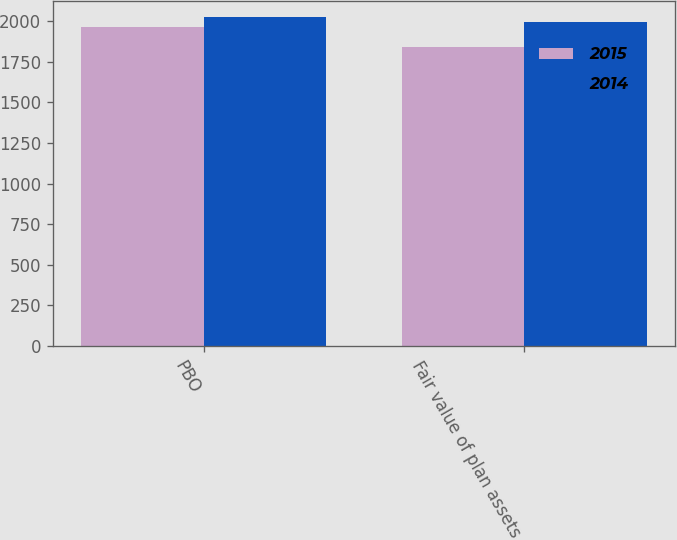<chart> <loc_0><loc_0><loc_500><loc_500><stacked_bar_chart><ecel><fcel>PBO<fcel>Fair value of plan assets<nl><fcel>2015<fcel>1964<fcel>1842<nl><fcel>2014<fcel>2023.4<fcel>1992.6<nl></chart> 